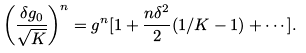<formula> <loc_0><loc_0><loc_500><loc_500>\left ( \frac { \delta g _ { 0 } } { \sqrt { K } } \right ) ^ { n } = g ^ { n } [ 1 + \frac { n \delta ^ { 2 } } { 2 } ( 1 / K - 1 ) + \cdots ] .</formula> 